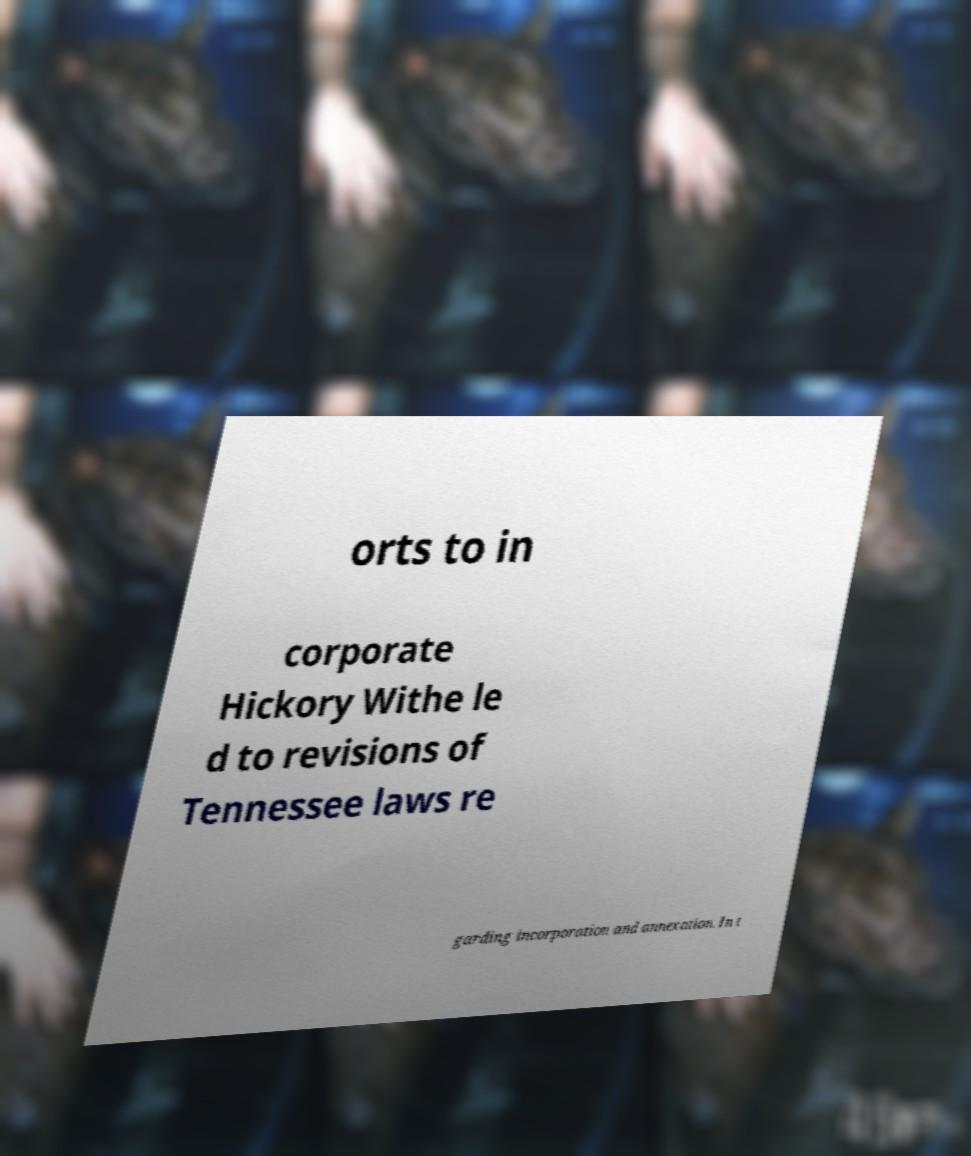Could you extract and type out the text from this image? orts to in corporate Hickory Withe le d to revisions of Tennessee laws re garding incorporation and annexation. In t 